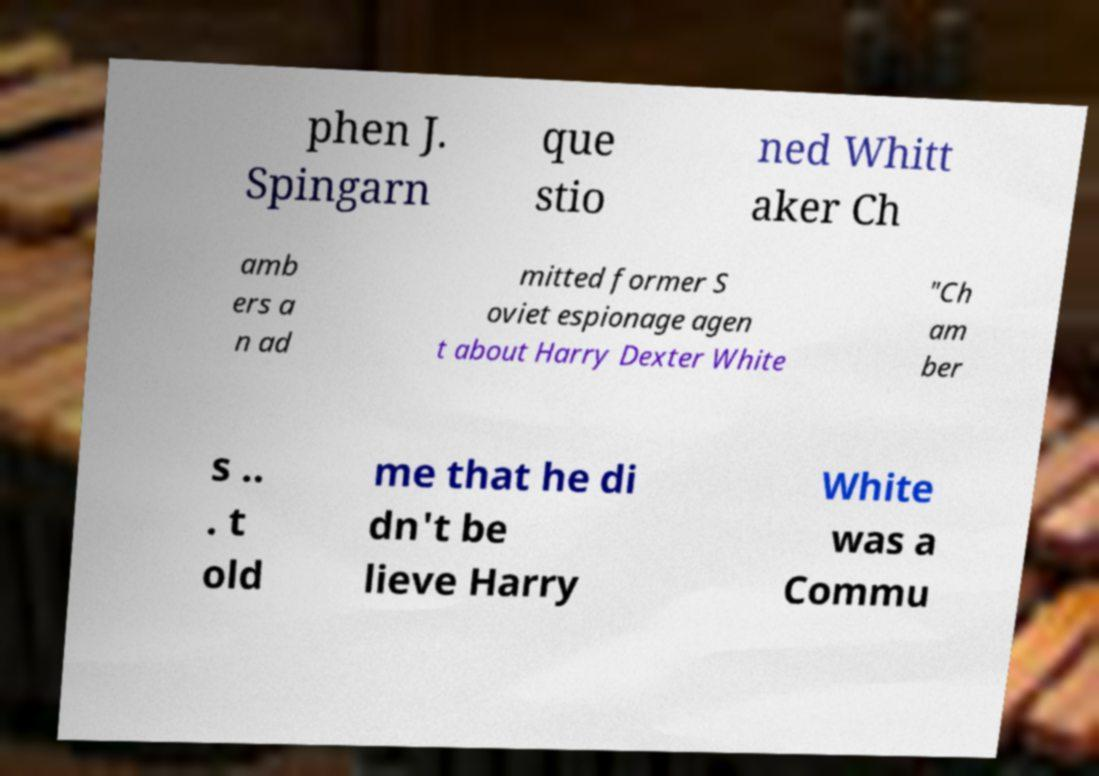Could you assist in decoding the text presented in this image and type it out clearly? phen J. Spingarn que stio ned Whitt aker Ch amb ers a n ad mitted former S oviet espionage agen t about Harry Dexter White "Ch am ber s .. . t old me that he di dn't be lieve Harry White was a Commu 